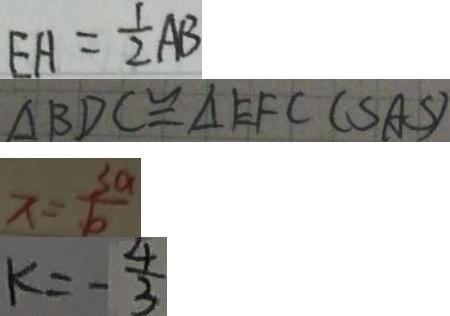Convert formula to latex. <formula><loc_0><loc_0><loc_500><loc_500>E H = \frac { 1 } { 2 } A B 
 \Delta B D C \cong \Delta E F C ( S A S ) 
 x = \frac { 3 a } { b } 
 k = - \frac { 4 } { 3 }</formula> 